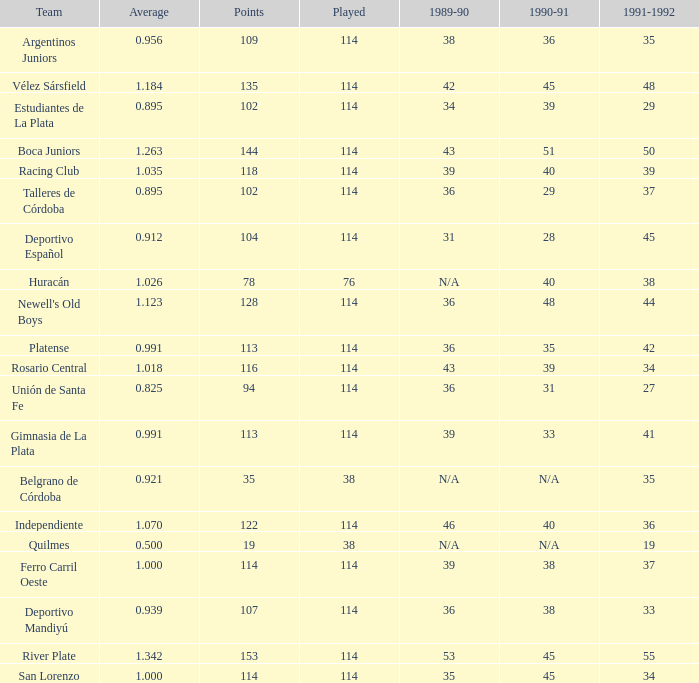How much 1991-1992 has a 1989-90 of 36, and an Average of 0.8250000000000001? 0.0. 